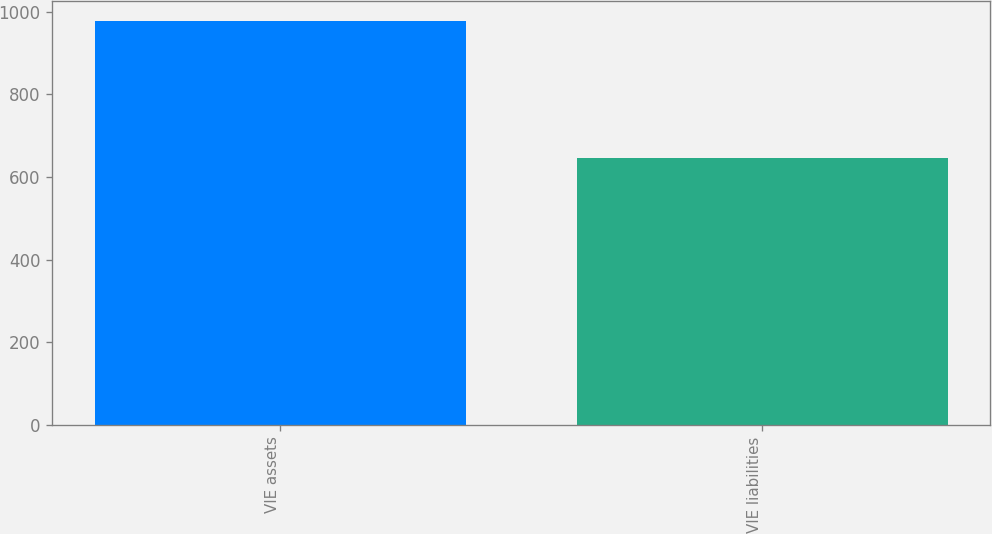Convert chart. <chart><loc_0><loc_0><loc_500><loc_500><bar_chart><fcel>VIE assets<fcel>VIE liabilities<nl><fcel>978<fcel>646<nl></chart> 